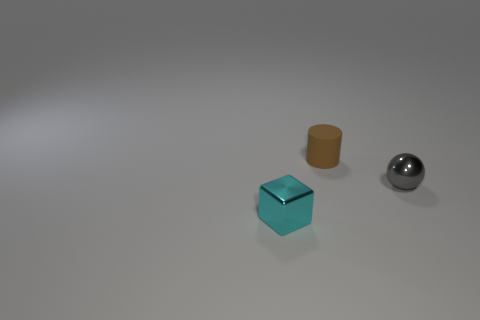Subtract all red cylinders. Subtract all purple cubes. How many cylinders are left? 1 Add 3 metal balls. How many objects exist? 6 Subtract all cylinders. How many objects are left? 2 Add 2 small brown objects. How many small brown objects are left? 3 Add 2 gray metal spheres. How many gray metal spheres exist? 3 Subtract 0 blue balls. How many objects are left? 3 Subtract all tiny brown rubber cylinders. Subtract all metallic blocks. How many objects are left? 1 